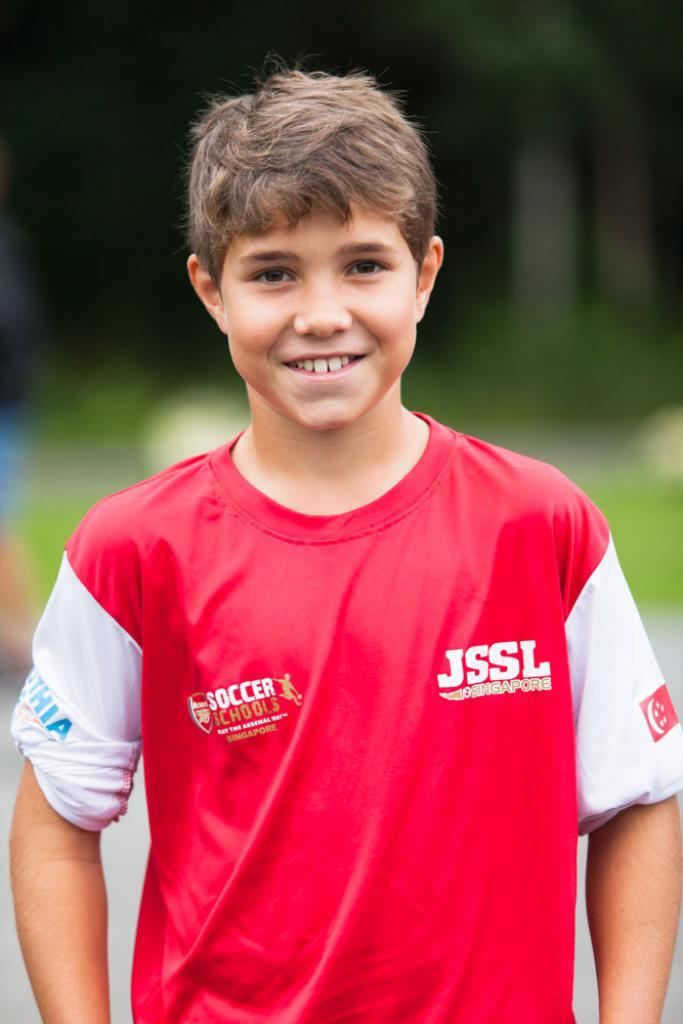<image>
Provide a brief description of the given image. A boy smiles for the camera and is wearing a soccer jersey. 